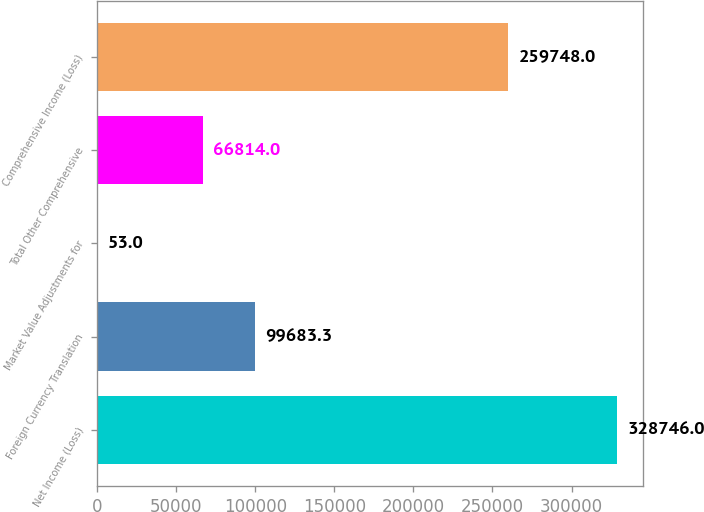Convert chart to OTSL. <chart><loc_0><loc_0><loc_500><loc_500><bar_chart><fcel>Net Income (Loss)<fcel>Foreign Currency Translation<fcel>Market Value Adjustments for<fcel>Total Other Comprehensive<fcel>Comprehensive Income (Loss)<nl><fcel>328746<fcel>99683.3<fcel>53<fcel>66814<fcel>259748<nl></chart> 